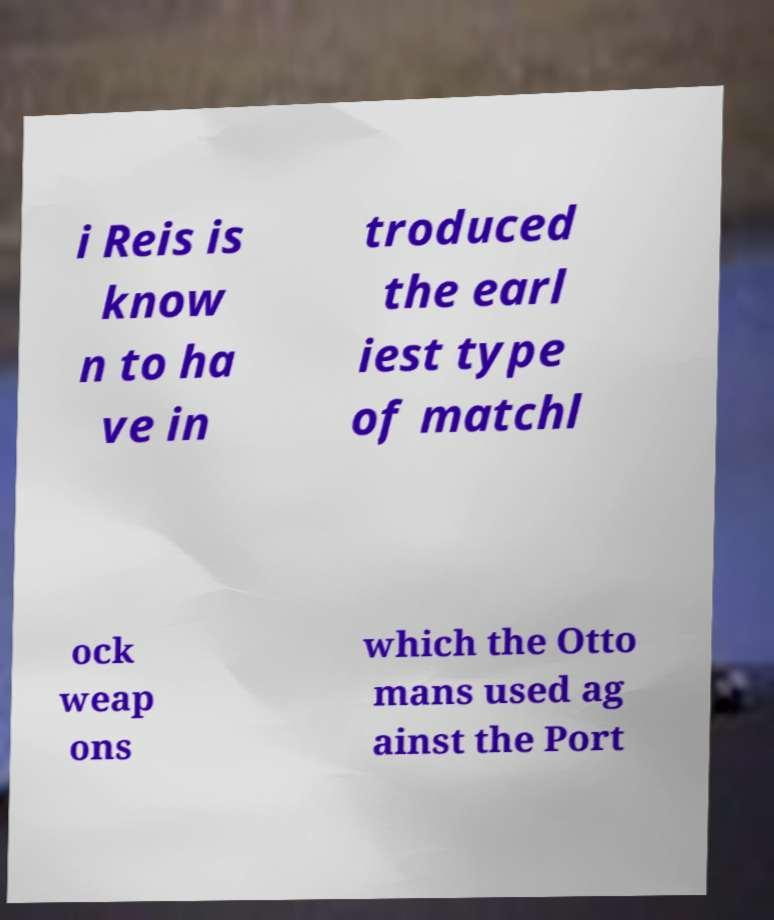Can you accurately transcribe the text from the provided image for me? i Reis is know n to ha ve in troduced the earl iest type of matchl ock weap ons which the Otto mans used ag ainst the Port 